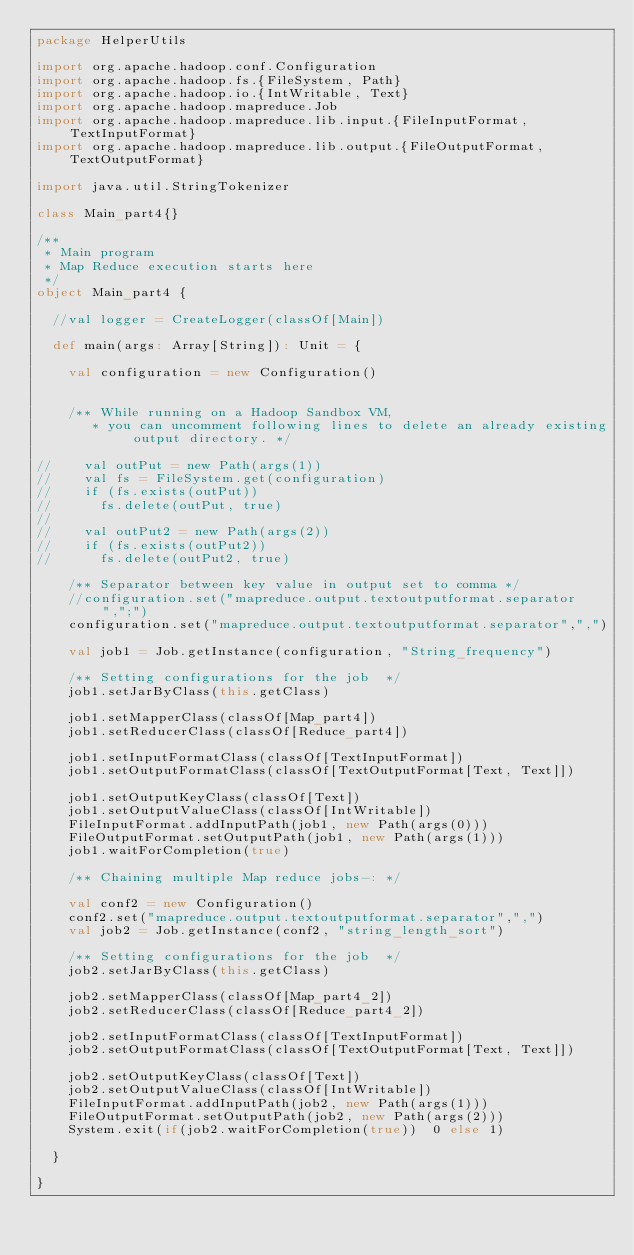Convert code to text. <code><loc_0><loc_0><loc_500><loc_500><_Scala_>package HelperUtils

import org.apache.hadoop.conf.Configuration
import org.apache.hadoop.fs.{FileSystem, Path}
import org.apache.hadoop.io.{IntWritable, Text}
import org.apache.hadoop.mapreduce.Job
import org.apache.hadoop.mapreduce.lib.input.{FileInputFormat, TextInputFormat}
import org.apache.hadoop.mapreduce.lib.output.{FileOutputFormat, TextOutputFormat}

import java.util.StringTokenizer

class Main_part4{}

/**
 * Main program
 * Map Reduce execution starts here
 */
object Main_part4 {

  //val logger = CreateLogger(classOf[Main])

  def main(args: Array[String]): Unit = {

    val configuration = new Configuration()


    /** While running on a Hadoop Sandbox VM,
       * you can uncomment following lines to delete an already existing output directory. */

//    val outPut = new Path(args(1))
//    val fs = FileSystem.get(configuration)
//    if (fs.exists(outPut))
//      fs.delete(outPut, true)
//
//    val outPut2 = new Path(args(2))
//    if (fs.exists(outPut2))
//      fs.delete(outPut2, true)

    /** Separator between key value in output set to comma */
    //configuration.set("mapreduce.output.textoutputformat.separator",";")
    configuration.set("mapreduce.output.textoutputformat.separator",",")

    val job1 = Job.getInstance(configuration, "String_frequency")

    /** Setting configurations for the job  */
    job1.setJarByClass(this.getClass)

    job1.setMapperClass(classOf[Map_part4])
    job1.setReducerClass(classOf[Reduce_part4])

    job1.setInputFormatClass(classOf[TextInputFormat])
    job1.setOutputFormatClass(classOf[TextOutputFormat[Text, Text]])

    job1.setOutputKeyClass(classOf[Text])
    job1.setOutputValueClass(classOf[IntWritable])
    FileInputFormat.addInputPath(job1, new Path(args(0)))
    FileOutputFormat.setOutputPath(job1, new Path(args(1)))
    job1.waitForCompletion(true)

    /** Chaining multiple Map reduce jobs-: */
    
    val conf2 = new Configuration()
    conf2.set("mapreduce.output.textoutputformat.separator",",")
    val job2 = Job.getInstance(conf2, "string_length_sort")

    /** Setting configurations for the job  */
    job2.setJarByClass(this.getClass)

    job2.setMapperClass(classOf[Map_part4_2])
    job2.setReducerClass(classOf[Reduce_part4_2])

    job2.setInputFormatClass(classOf[TextInputFormat])
    job2.setOutputFormatClass(classOf[TextOutputFormat[Text, Text]])

    job2.setOutputKeyClass(classOf[Text])
    job2.setOutputValueClass(classOf[IntWritable])
    FileInputFormat.addInputPath(job2, new Path(args(1)))
    FileOutputFormat.setOutputPath(job2, new Path(args(2)))
    System.exit(if(job2.waitForCompletion(true))  0 else 1)

  }

}
</code> 